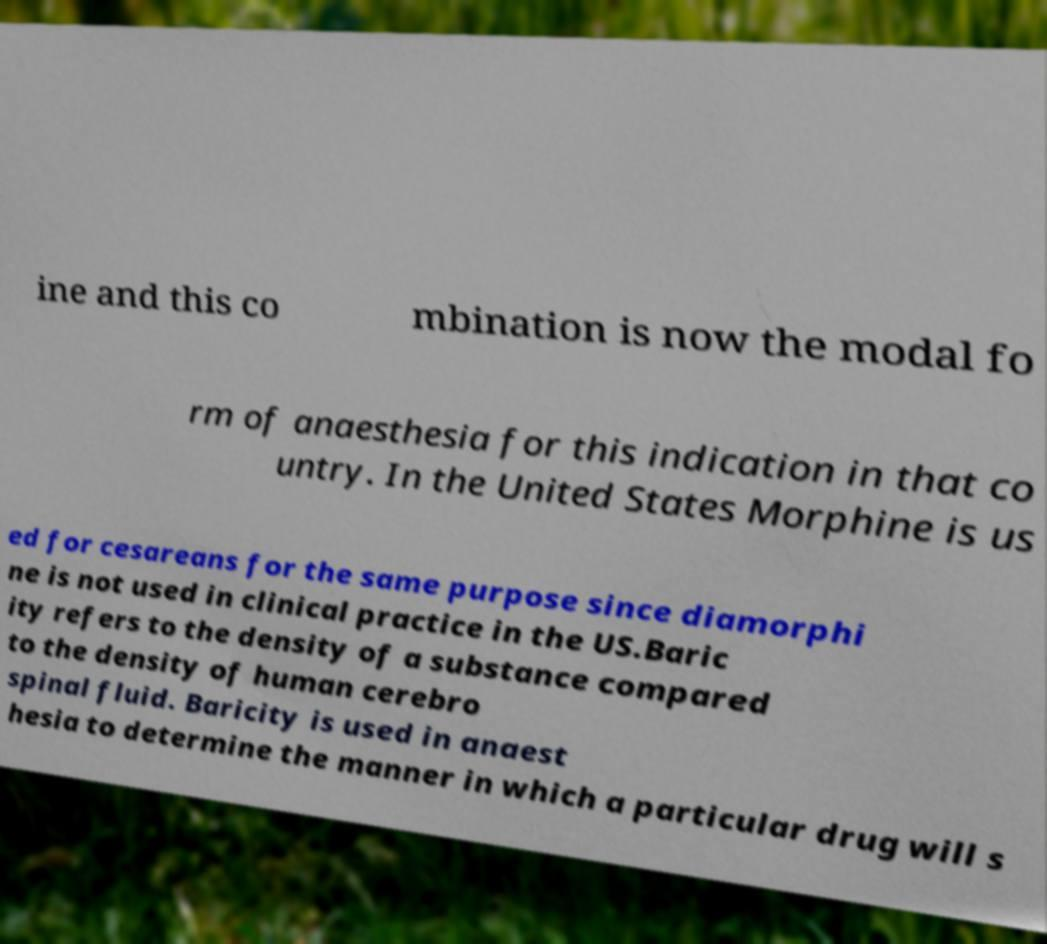I need the written content from this picture converted into text. Can you do that? ine and this co mbination is now the modal fo rm of anaesthesia for this indication in that co untry. In the United States Morphine is us ed for cesareans for the same purpose since diamorphi ne is not used in clinical practice in the US.Baric ity refers to the density of a substance compared to the density of human cerebro spinal fluid. Baricity is used in anaest hesia to determine the manner in which a particular drug will s 